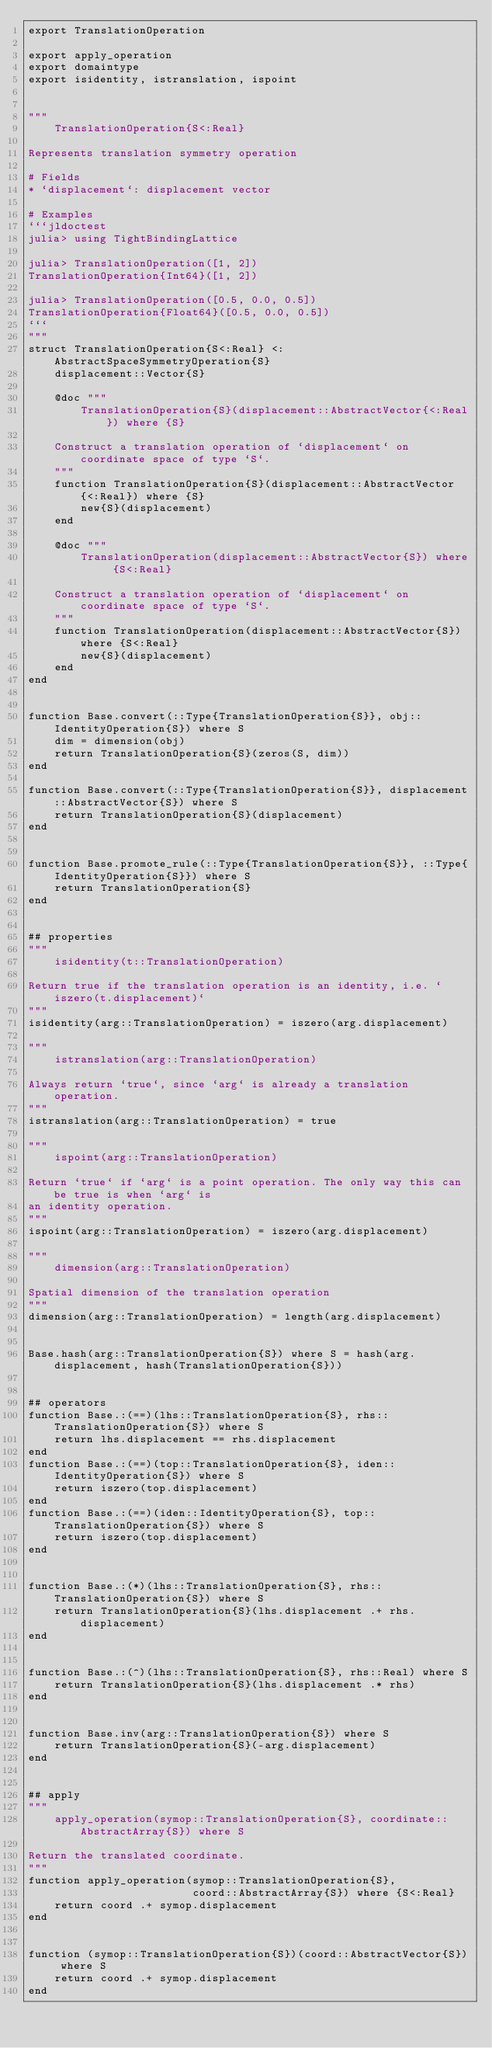Convert code to text. <code><loc_0><loc_0><loc_500><loc_500><_Julia_>export TranslationOperation

export apply_operation
export domaintype
export isidentity, istranslation, ispoint


"""
    TranslationOperation{S<:Real}

Represents translation symmetry operation

# Fields
* `displacement`: displacement vector

# Examples
```jldoctest
julia> using TightBindingLattice

julia> TranslationOperation([1, 2])
TranslationOperation{Int64}([1, 2])

julia> TranslationOperation([0.5, 0.0, 0.5])
TranslationOperation{Float64}([0.5, 0.0, 0.5])
```
"""
struct TranslationOperation{S<:Real} <:AbstractSpaceSymmetryOperation{S}
    displacement::Vector{S}

    @doc """
        TranslationOperation{S}(displacement::AbstractVector{<:Real}) where {S}

    Construct a translation operation of `displacement` on coordinate space of type `S`.
    """
    function TranslationOperation{S}(displacement::AbstractVector{<:Real}) where {S}
        new{S}(displacement)
    end

    @doc """
        TranslationOperation(displacement::AbstractVector{S}) where {S<:Real}

    Construct a translation operation of `displacement` on coordinate space of type `S`.
    """
    function TranslationOperation(displacement::AbstractVector{S}) where {S<:Real}
        new{S}(displacement)
    end
end


function Base.convert(::Type{TranslationOperation{S}}, obj::IdentityOperation{S}) where S
    dim = dimension(obj)
    return TranslationOperation{S}(zeros(S, dim))
end

function Base.convert(::Type{TranslationOperation{S}}, displacement::AbstractVector{S}) where S
    return TranslationOperation{S}(displacement)
end


function Base.promote_rule(::Type{TranslationOperation{S}}, ::Type{IdentityOperation{S}}) where S
    return TranslationOperation{S}
end


## properties
"""
    isidentity(t::TranslationOperation)

Return true if the translation operation is an identity, i.e. `iszero(t.displacement)`
"""
isidentity(arg::TranslationOperation) = iszero(arg.displacement)

"""
    istranslation(arg::TranslationOperation)

Always return `true`, since `arg` is already a translation operation.
"""
istranslation(arg::TranslationOperation) = true

"""
    ispoint(arg::TranslationOperation)

Return `true` if `arg` is a point operation. The only way this can be true is when `arg` is
an identity operation.
"""
ispoint(arg::TranslationOperation) = iszero(arg.displacement)

"""
    dimension(arg::TranslationOperation)

Spatial dimension of the translation operation
"""
dimension(arg::TranslationOperation) = length(arg.displacement)


Base.hash(arg::TranslationOperation{S}) where S = hash(arg.displacement, hash(TranslationOperation{S}))


## operators
function Base.:(==)(lhs::TranslationOperation{S}, rhs::TranslationOperation{S}) where S
    return lhs.displacement == rhs.displacement
end
function Base.:(==)(top::TranslationOperation{S}, iden::IdentityOperation{S}) where S
    return iszero(top.displacement)
end
function Base.:(==)(iden::IdentityOperation{S}, top::TranslationOperation{S}) where S
    return iszero(top.displacement)
end


function Base.:(*)(lhs::TranslationOperation{S}, rhs::TranslationOperation{S}) where S
    return TranslationOperation{S}(lhs.displacement .+ rhs.displacement)
end


function Base.:(^)(lhs::TranslationOperation{S}, rhs::Real) where S
    return TranslationOperation{S}(lhs.displacement .* rhs)
end


function Base.inv(arg::TranslationOperation{S}) where S
    return TranslationOperation{S}(-arg.displacement)
end


## apply
"""
    apply_operation(symop::TranslationOperation{S}, coordinate::AbstractArray{S}) where S

Return the translated coordinate.
"""
function apply_operation(symop::TranslationOperation{S},
                         coord::AbstractArray{S}) where {S<:Real}
    return coord .+ symop.displacement
end


function (symop::TranslationOperation{S})(coord::AbstractVector{S}) where S
    return coord .+ symop.displacement
end
</code> 